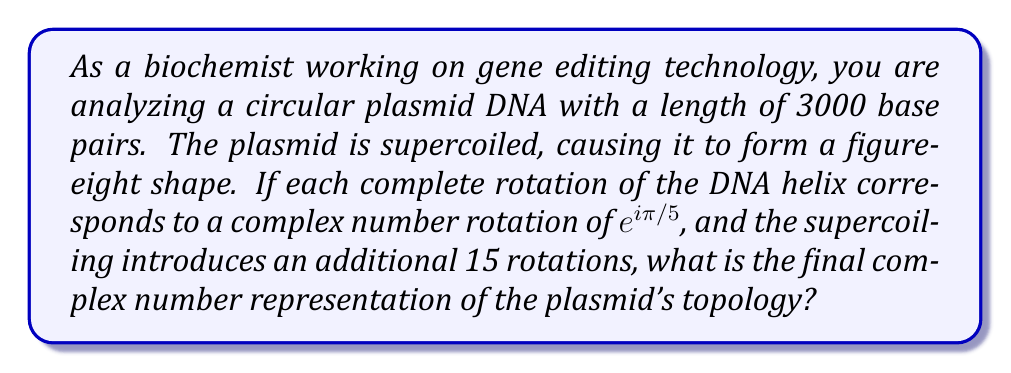Give your solution to this math problem. Let's approach this step-by-step:

1) First, we need to calculate the number of rotations in the normal, non-supercoiled plasmid:
   - One complete rotation of DNA helix occurs every 10.5 base pairs
   - Number of rotations = 3000 / 10.5 ≈ 285.71 rotations

2) Each rotation corresponds to $e^{i\pi/5}$, so the total rotation for the non-supercoiled plasmid is:
   $$(e^{i\pi/5})^{285.71} = e^{i\pi \cdot 285.71/5} = e^{i\cdot 57.142\pi}$$

3) The supercoiling introduces an additional 15 rotations:
   $$(e^{i\pi/5})^{15} = e^{i\pi \cdot 15/5} = e^{i\cdot 3\pi}$$

4) To get the final topology, we multiply these rotations:
   $$e^{i\cdot 57.142\pi} \cdot e^{i\cdot 3\pi} = e^{i\cdot 60.142\pi}$$

5) We can simplify this by considering that a full rotation is $2\pi$:
   $$e^{i\cdot 60.142\pi} = e^{i\cdot 0.142\pi} = \cos(0.142\pi) + i\sin(0.142\pi)$$

6) Calculating the final values:
   $$\cos(0.142\pi) \approx 0.8090$$
   $$\sin(0.142\pi) \approx 0.5878$$

Therefore, the final complex number representation is approximately $0.8090 + 0.5878i$.
Answer: $0.8090 + 0.5878i$ 